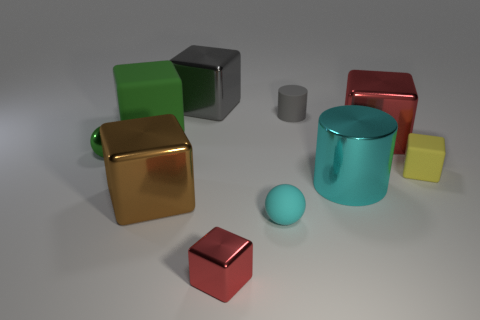Subtract all gray cubes. How many cubes are left? 5 Subtract all yellow spheres. How many red blocks are left? 2 Subtract 4 cubes. How many cubes are left? 2 Subtract all green blocks. How many blocks are left? 5 Subtract all gray blocks. Subtract all cyan cylinders. How many blocks are left? 5 Subtract all spheres. How many objects are left? 8 Subtract all large red rubber objects. Subtract all big metallic things. How many objects are left? 6 Add 5 red cubes. How many red cubes are left? 7 Add 2 tiny metal blocks. How many tiny metal blocks exist? 3 Subtract 0 blue spheres. How many objects are left? 10 